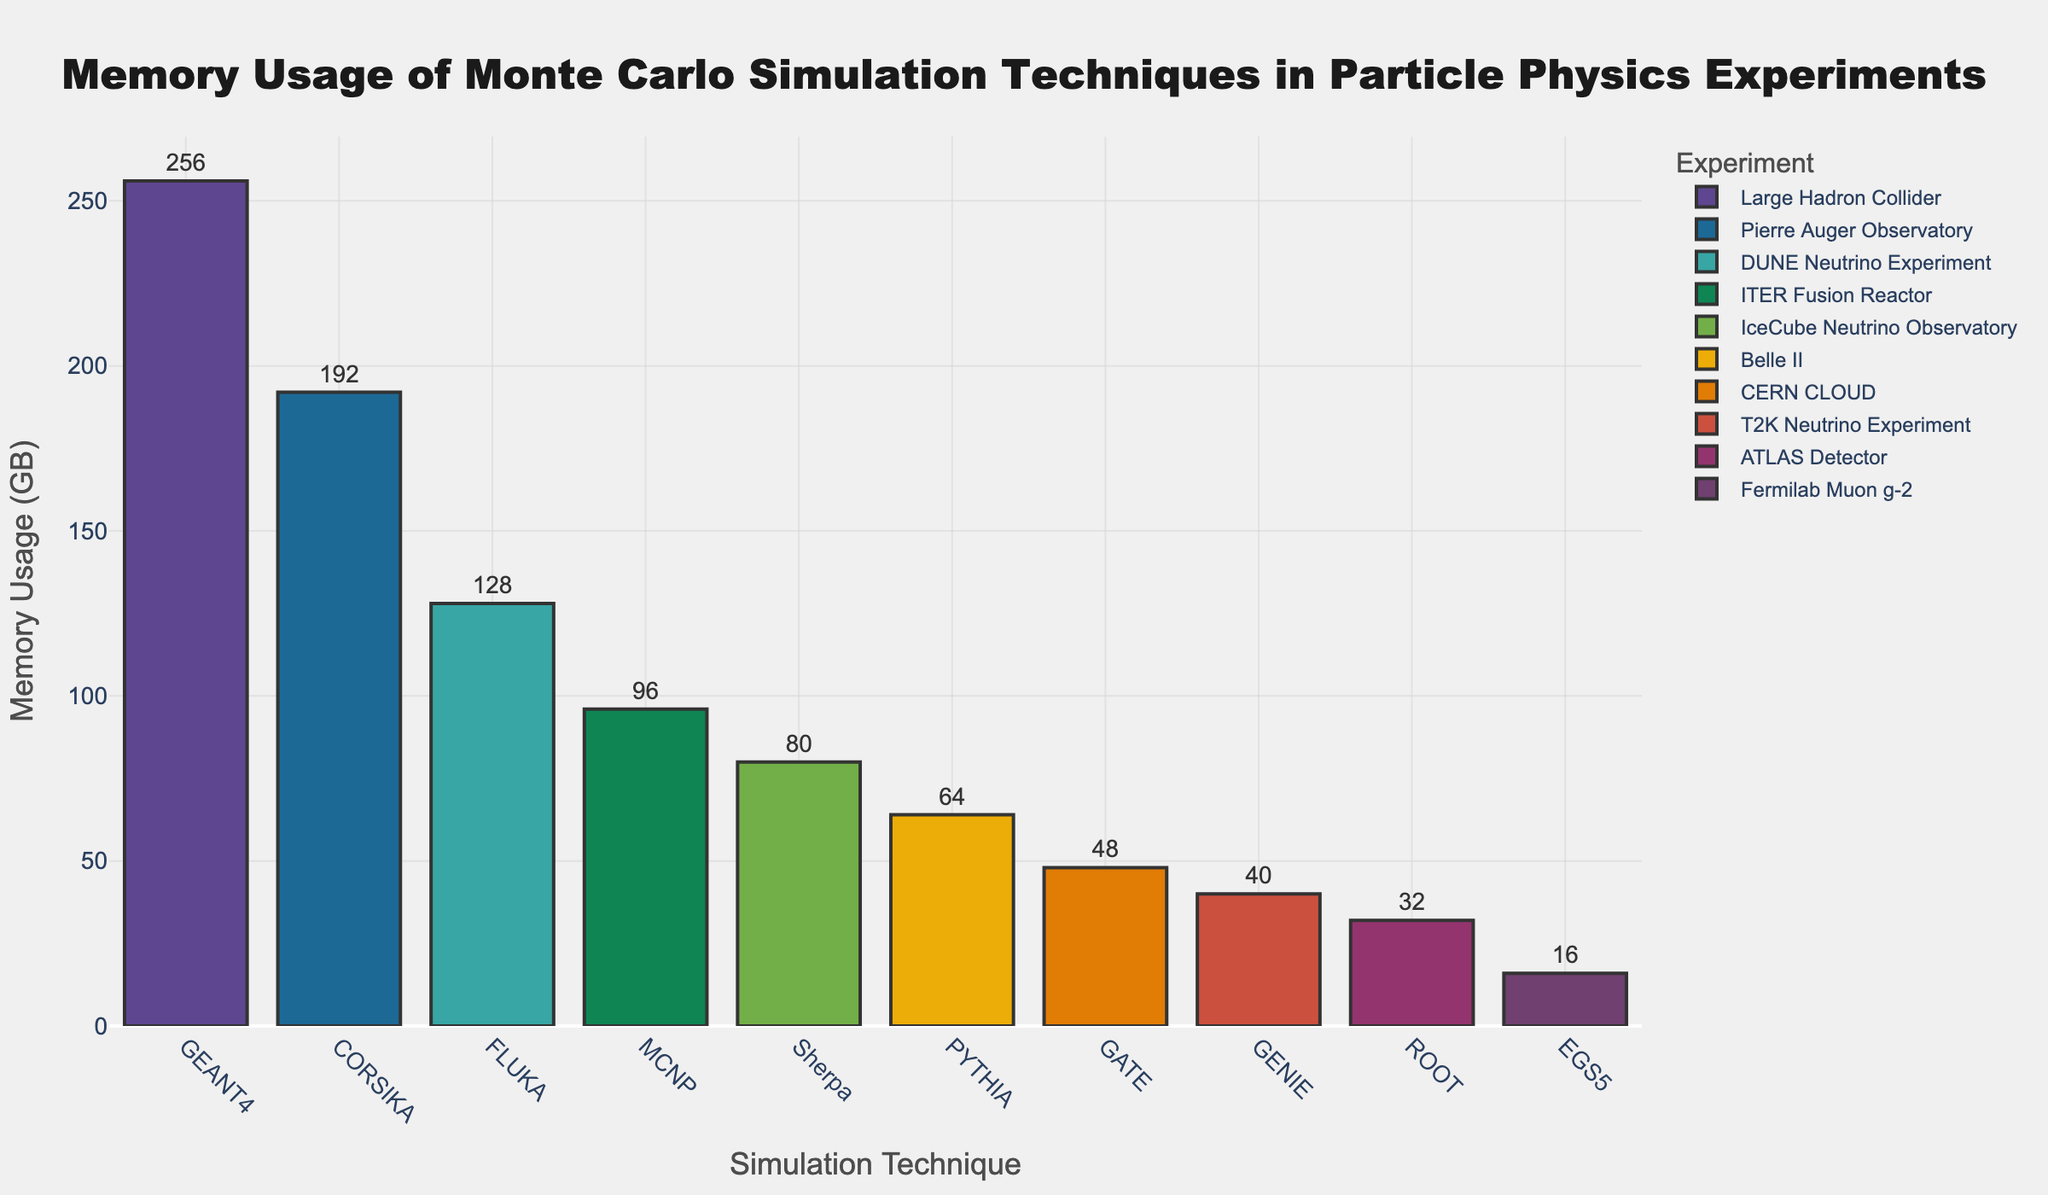What's the simulation technique with the highest memory usage? The highest memory usage bar on the chart is for the GEANT4 technique, which reaches the topmost point of the y-axis.
Answer: GEANT4 Which experiment corresponds to the technique with the lowest memory usage? The technique with the lowest memory usage is EGS5, and by looking at the color and label, it corresponds to the Fermilab Muon g-2 experiment.
Answer: Fermilab Muon g-2 Compare the memory usage between GEANT4 and CORSIKA; which one uses more memory and by how much? GEANT4 uses 256 GB of memory, while CORSIKA uses 192 GB. The difference in their memory usage is 256 - 192 = 64 GB.
Answer: GEANT4 by 64 GB Which technique is associated with DUNE Neutrino Experiment and how much memory does it use? By referring to the colors and labels of the bars, FLUKA is associated with the DUNE Neutrino Experiment and uses 128 GB of memory.
Answer: FLUKA, 128 GB What's the total memory usage of techniques used in neutrino-related experiments? Techniques for neutrino-related experiments are FLUKA (DUNE, 128 GB), Sherpa (IceCube, 80 GB), and GENIE (T2K, 40 GB). The total is 128 + 80 + 40 = 248 GB.
Answer: 248 GB Identify the technique used in the ATLAS Detector experiment and its memory usage, then compare it with the technique used in the Large Hadron Collider. ROOT is used in the ATLAS Detector and uses 32 GB. GEANT4 is used in the Large Hadron Collider and uses 256 GB. The difference is 256 - 32 = 224 GB.
Answer: ROOT: 32 GB, GEANT4 by 224 GB Which techniques have memory usage amounts between 40 GB and 100 GB? By visually inspecting the heights of the bars within the range of 40 GB to 100 GB on the y-axis, MCNP (96 GB), Sherpa (80 GB), GATE (48 GB), and GENIE (40 GB) fall within this range.
Answer: MCNP, Sherpa, GATE, GENIE Which technique has the highest memory usage for fusion energy experiments? Only MCNP is associated with the ITER Fusion Reactor, and it uses 96 GB, which is the highest for fusion energy experiments listed.
Answer: MCNP, 96 GB 